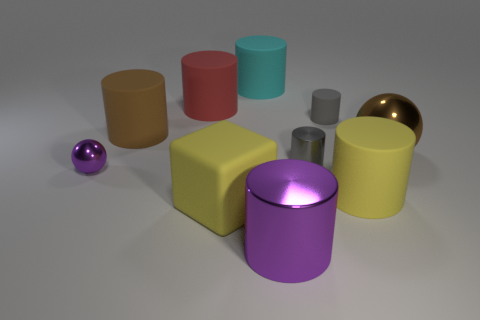Subtract all green balls. How many gray cylinders are left? 2 Subtract 4 cylinders. How many cylinders are left? 3 Subtract all red cylinders. How many cylinders are left? 6 Subtract all large rubber cylinders. How many cylinders are left? 3 Subtract all cyan cylinders. Subtract all purple spheres. How many cylinders are left? 6 Subtract all cubes. How many objects are left? 9 Subtract 0 red spheres. How many objects are left? 10 Subtract all gray matte objects. Subtract all red rubber things. How many objects are left? 8 Add 2 big cyan things. How many big cyan things are left? 3 Add 3 large blocks. How many large blocks exist? 4 